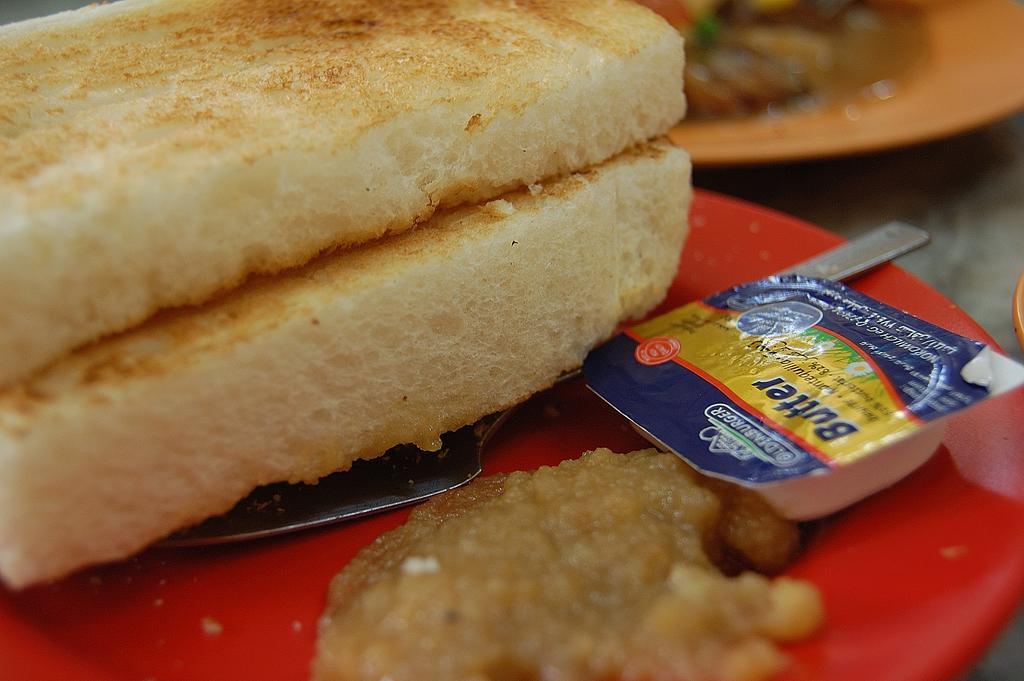Describe this image in one or two sentences. In this image we can see food item and knife are kept on the red color plate. The background of the image is slightly blurred, where we can see another plate with some food item. 